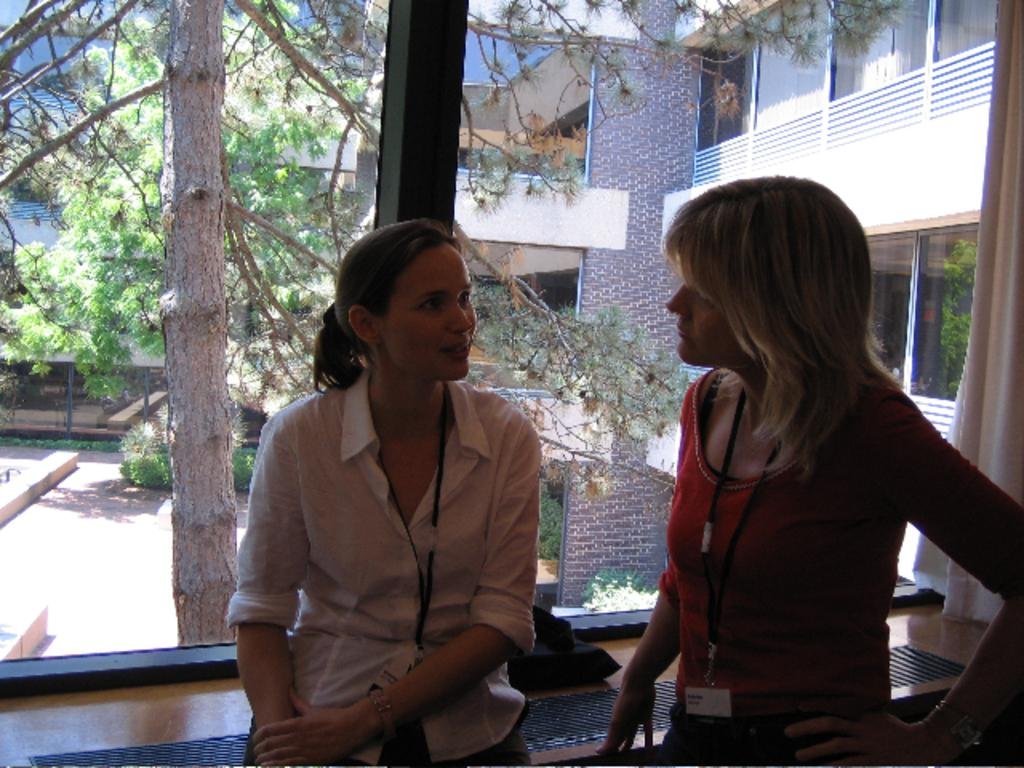How many people are in the image? There are two women in the image. Where are the women standing in relation to the window? The women are standing in front of a window. What can be seen through the window? Trees and the trunk of a tree are visible through the window. What type of tin can be seen on the table in the image? There is no table or tin present in the image. What is the women drinking in the image? The provided facts do not mention any drinks or beverages in the image. 